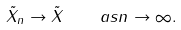<formula> <loc_0><loc_0><loc_500><loc_500>\tilde { X } _ { n } \to \tilde { X } \quad a s n \to \infty .</formula> 